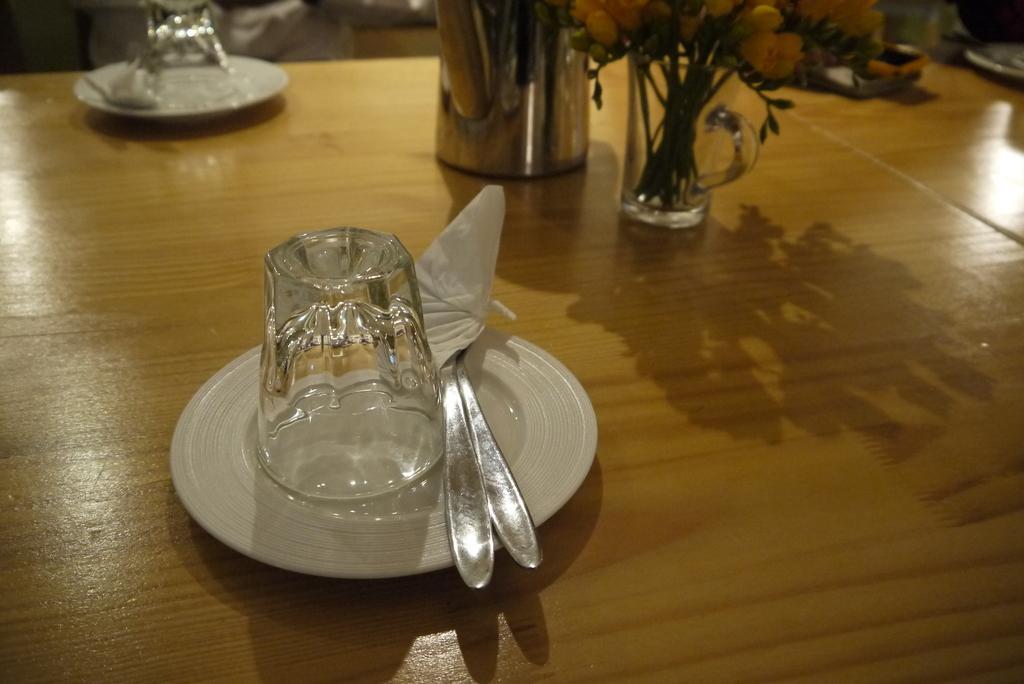In one or two sentences, can you explain what this image depicts? In the picture there is a plate on which there are spoon,glass along with tissue,this is on a dining table and on the top right side there are flower vase. 